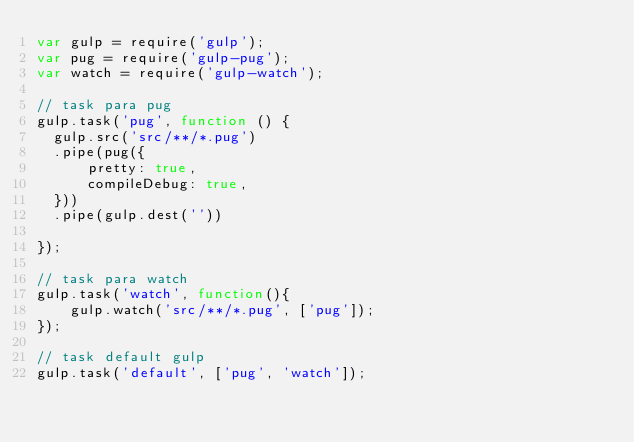Convert code to text. <code><loc_0><loc_0><loc_500><loc_500><_JavaScript_>var gulp = require('gulp');
var pug = require('gulp-pug');
var watch = require('gulp-watch');

// task para pug  
gulp.task('pug', function () {
  gulp.src('src/**/*.pug')
  .pipe(pug({
      pretty: true,
      compileDebug: true,
  }))
  .pipe(gulp.dest(''))

});

// task para watch 
gulp.task('watch', function(){
    gulp.watch('src/**/*.pug', ['pug']);
});

// task default gulp
gulp.task('default', ['pug', 'watch']);</code> 